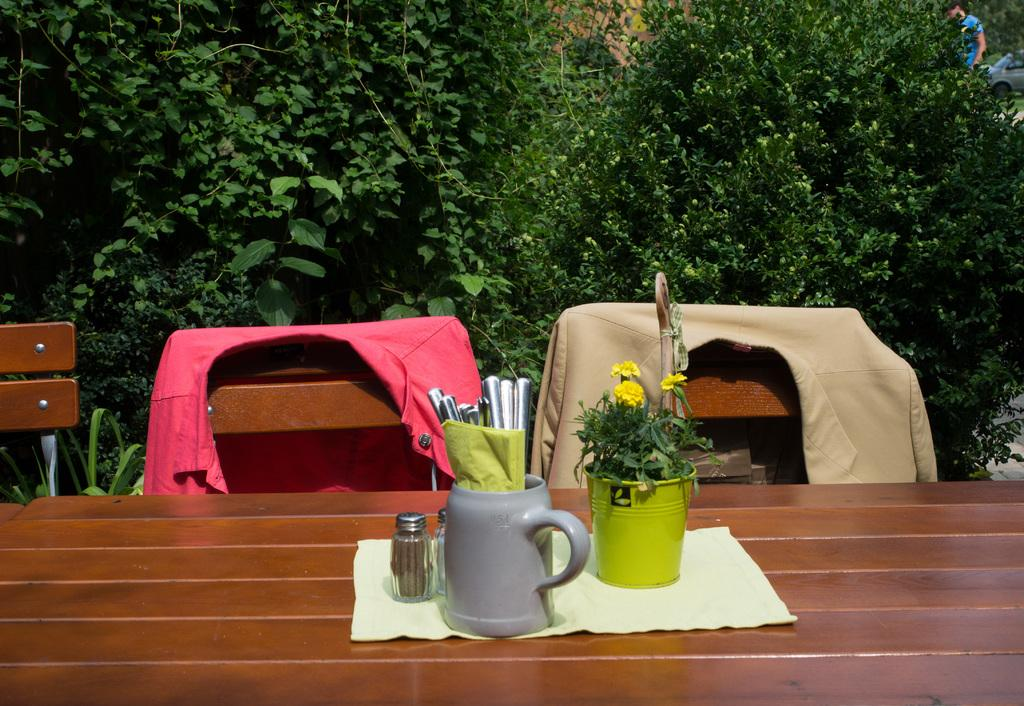What type of furniture is present in the image? There is a table and chairs in the image. What objects can be seen on the table? There is a cup, a spoon, a shaker, and a flower vase on the table. What is the purpose of the shaker on the table? The shaker on the table is likely used for adding seasoning or flavor to food or drinks. What is the condition of the chair in the image? There are clothes on one of the chairs, suggesting that it is being used for holding clothes. What can be seen in the background of the image? There are trees in the background of the image. What type of ball is being used by the mom in the image? There is no mom or ball present in the image. What does the porter do with the luggage in the image? There is no porter or luggage present in the image. 